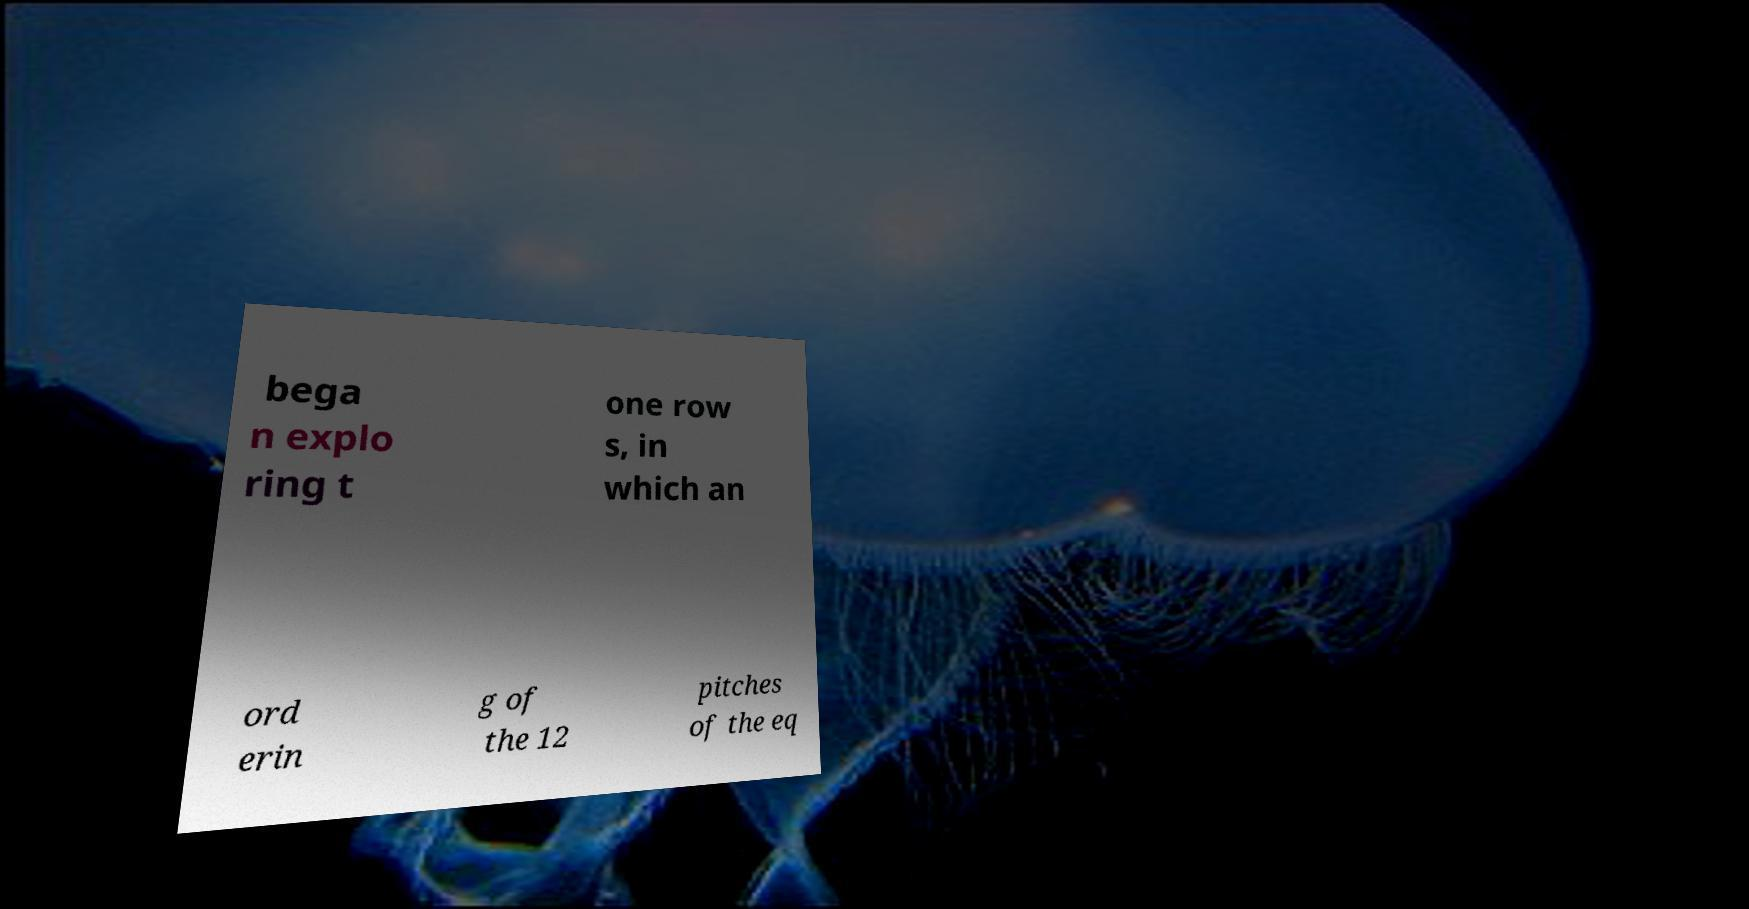Please read and relay the text visible in this image. What does it say? bega n explo ring t one row s, in which an ord erin g of the 12 pitches of the eq 